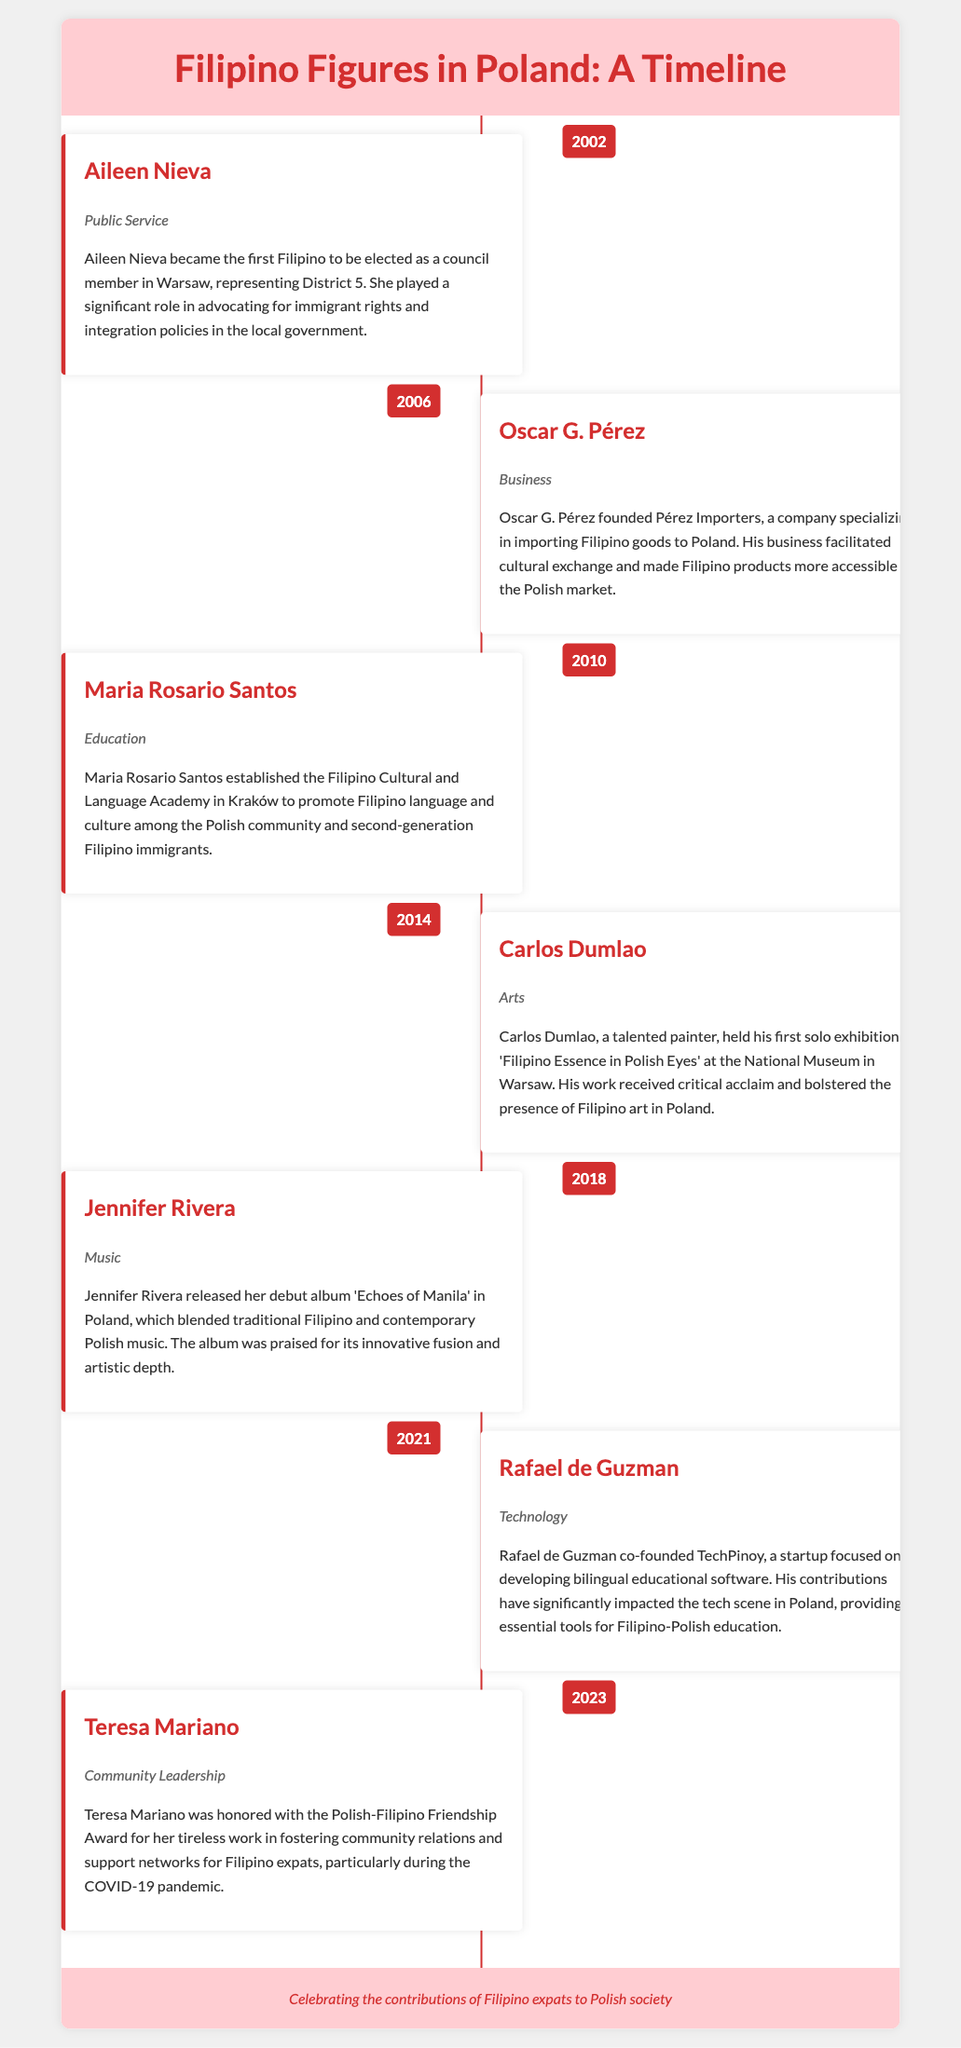What year was Aileen Nieva elected as a council member? Aileen Nieva was elected as a council member in 2002, as indicated in the timeline.
Answer: 2002 Which field did Oscar G. Pérez contribute to? Oscar G. Pérez is recognized for his contributions in the field of Business according to the document.
Answer: Business What significant cultural initiative did Maria Rosario Santos start? Maria Rosario Santos established the Filipino Cultural and Language Academy to promote Filipino culture and language.
Answer: Filipino Cultural and Language Academy How many years apart are the contributions of Carlos Dumlao and Jennifer Rivera? Carlos Dumlao's contribution was in 2014 and Jennifer Rivera's in 2018, making it four years apart.
Answer: 4 years What award did Teresa Mariano receive in 2023? Teresa Mariano was honored with the Polish-Filipino Friendship Award for her community work.
Answer: Polish-Filipino Friendship Award Which Filipino figure focused on technology? Rafael de Guzman co-founded a startup focused on developing educational software in the technology field.
Answer: Rafael de Guzman Which art exhibition was held at the National Museum in Warsaw? Carlos Dumlao held the exhibition titled 'Filipino Essence in Polish Eyes' at the National Museum.
Answer: Filipino Essence in Polish Eyes In which city did the Filipino Cultural and Language Academy open? The academy established by Maria Rosario Santos is located in Kraków according to the timeline.
Answer: Kraków 